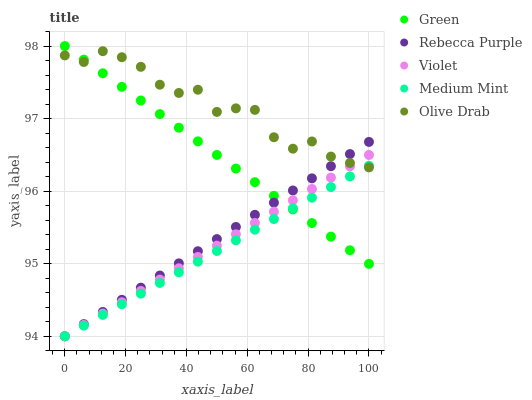Does Medium Mint have the minimum area under the curve?
Answer yes or no. Yes. Does Olive Drab have the maximum area under the curve?
Answer yes or no. Yes. Does Green have the minimum area under the curve?
Answer yes or no. No. Does Green have the maximum area under the curve?
Answer yes or no. No. Is Violet the smoothest?
Answer yes or no. Yes. Is Olive Drab the roughest?
Answer yes or no. Yes. Is Green the smoothest?
Answer yes or no. No. Is Green the roughest?
Answer yes or no. No. Does Medium Mint have the lowest value?
Answer yes or no. Yes. Does Green have the lowest value?
Answer yes or no. No. Does Green have the highest value?
Answer yes or no. Yes. Does Rebecca Purple have the highest value?
Answer yes or no. No. Does Olive Drab intersect Violet?
Answer yes or no. Yes. Is Olive Drab less than Violet?
Answer yes or no. No. Is Olive Drab greater than Violet?
Answer yes or no. No. 